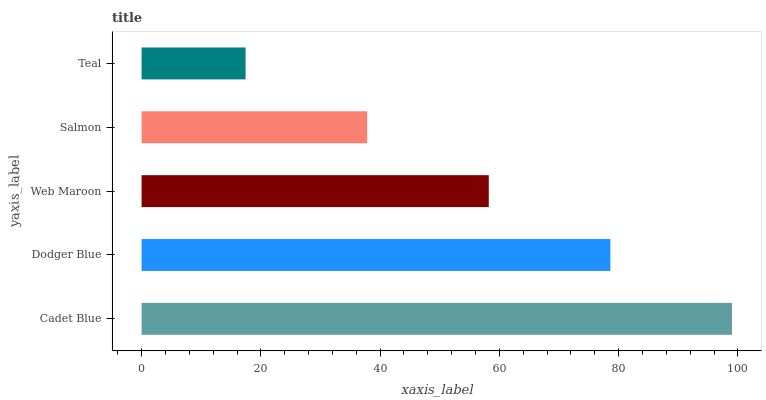Is Teal the minimum?
Answer yes or no. Yes. Is Cadet Blue the maximum?
Answer yes or no. Yes. Is Dodger Blue the minimum?
Answer yes or no. No. Is Dodger Blue the maximum?
Answer yes or no. No. Is Cadet Blue greater than Dodger Blue?
Answer yes or no. Yes. Is Dodger Blue less than Cadet Blue?
Answer yes or no. Yes. Is Dodger Blue greater than Cadet Blue?
Answer yes or no. No. Is Cadet Blue less than Dodger Blue?
Answer yes or no. No. Is Web Maroon the high median?
Answer yes or no. Yes. Is Web Maroon the low median?
Answer yes or no. Yes. Is Teal the high median?
Answer yes or no. No. Is Teal the low median?
Answer yes or no. No. 